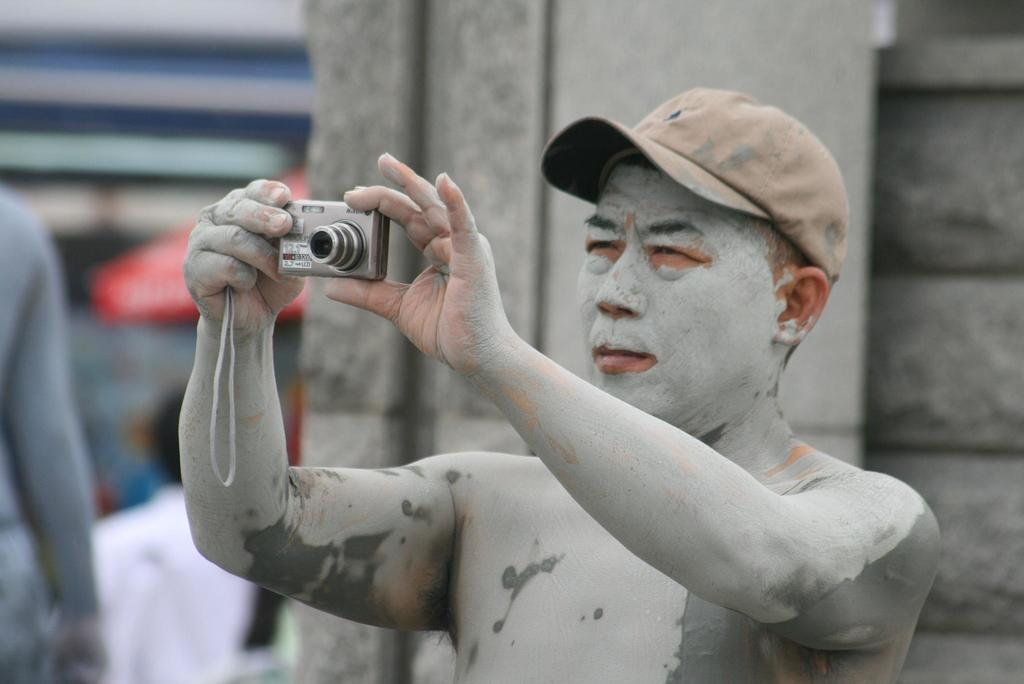What is the man in the image wearing on his head? The man is wearing a cap in the image. What is the man holding in his hand? The man is holding a camera in his hand. What can be seen on the man's body? The man has a cement color powder on his body. How many people are present in the image? There are two people in the image. What type of straw is being used in the battle depicted in the image? There is no battle or straw present in the image; it features a man wearing a cap and holding a camera, with another man nearby. 